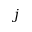Convert formula to latex. <formula><loc_0><loc_0><loc_500><loc_500>j</formula> 